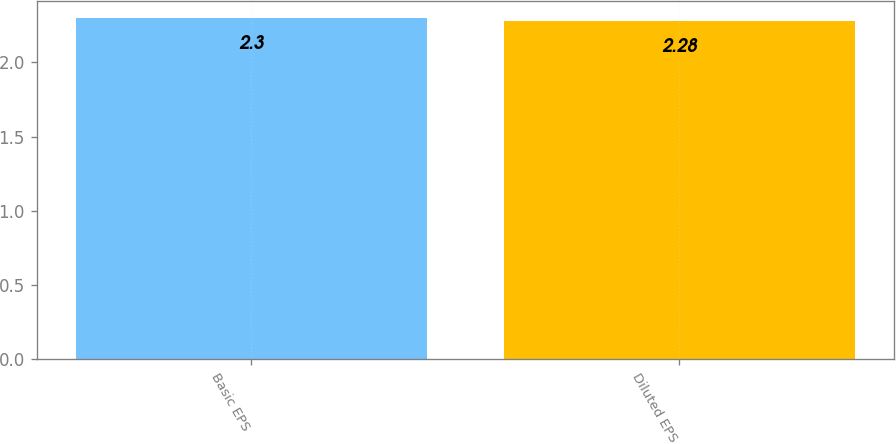<chart> <loc_0><loc_0><loc_500><loc_500><bar_chart><fcel>Basic EPS<fcel>Diluted EPS<nl><fcel>2.3<fcel>2.28<nl></chart> 